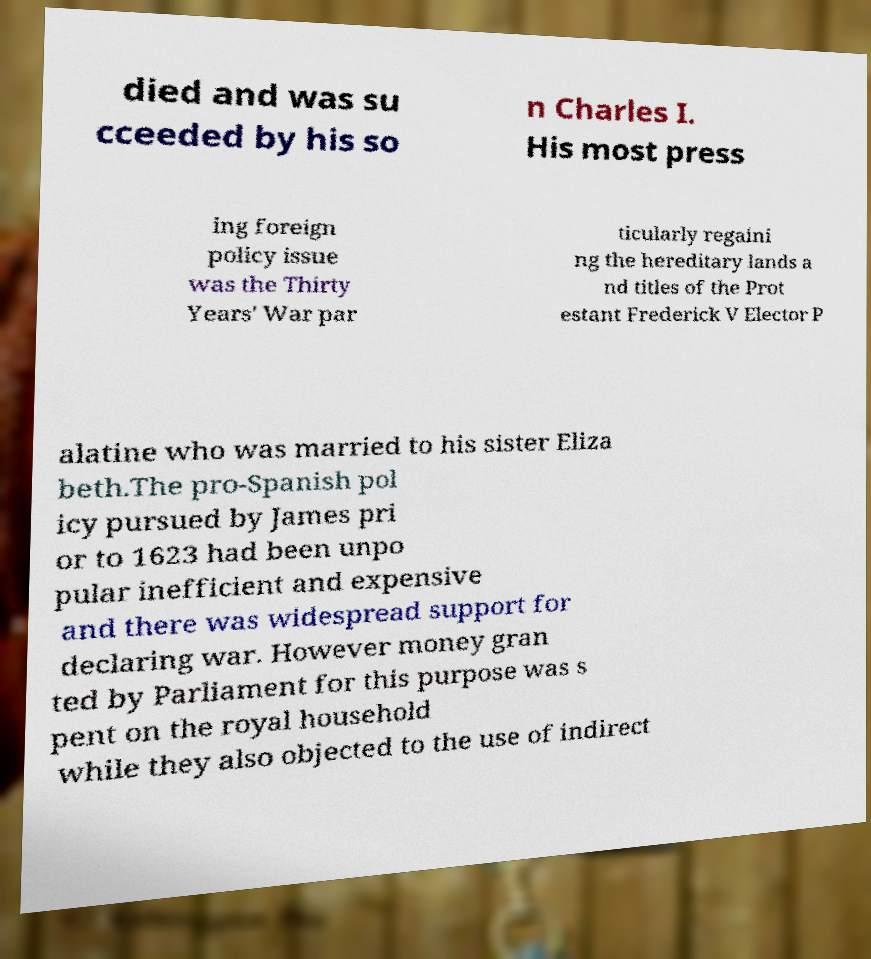What messages or text are displayed in this image? I need them in a readable, typed format. died and was su cceeded by his so n Charles I. His most press ing foreign policy issue was the Thirty Years' War par ticularly regaini ng the hereditary lands a nd titles of the Prot estant Frederick V Elector P alatine who was married to his sister Eliza beth.The pro-Spanish pol icy pursued by James pri or to 1623 had been unpo pular inefficient and expensive and there was widespread support for declaring war. However money gran ted by Parliament for this purpose was s pent on the royal household while they also objected to the use of indirect 